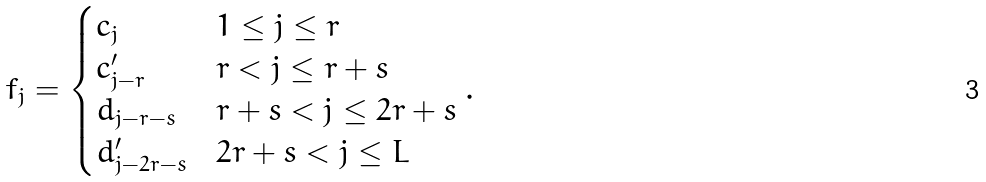<formula> <loc_0><loc_0><loc_500><loc_500>f _ { j } = \begin{cases} c _ { j } & 1 \leq j \leq r \\ c ^ { \prime } _ { j - r } & r < j \leq r + s \\ d _ { j - r - s } & r + s < j \leq 2 r + s \\ d ^ { \prime } _ { j - 2 r - s } & 2 r + s < j \leq L \end{cases} .</formula> 